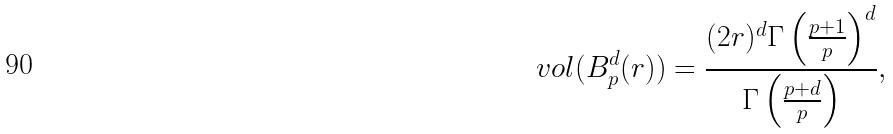<formula> <loc_0><loc_0><loc_500><loc_500>\ v o l ( B ^ { d } _ { p } ( r ) ) = \frac { ( 2 r ) ^ { d } \Gamma \left ( \frac { p + 1 } { p } \right ) ^ { d } } { \Gamma \left ( \frac { p + d } { p } \right ) } ,</formula> 